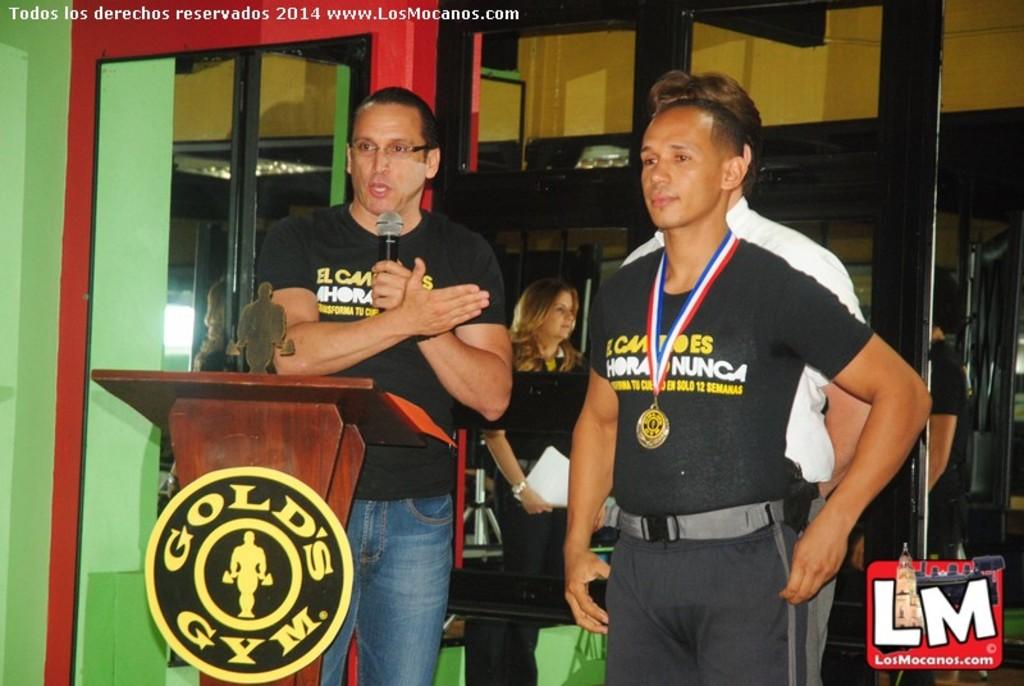What is the business name of the gym advertised?
Your answer should be very brief. Gold's gym. 